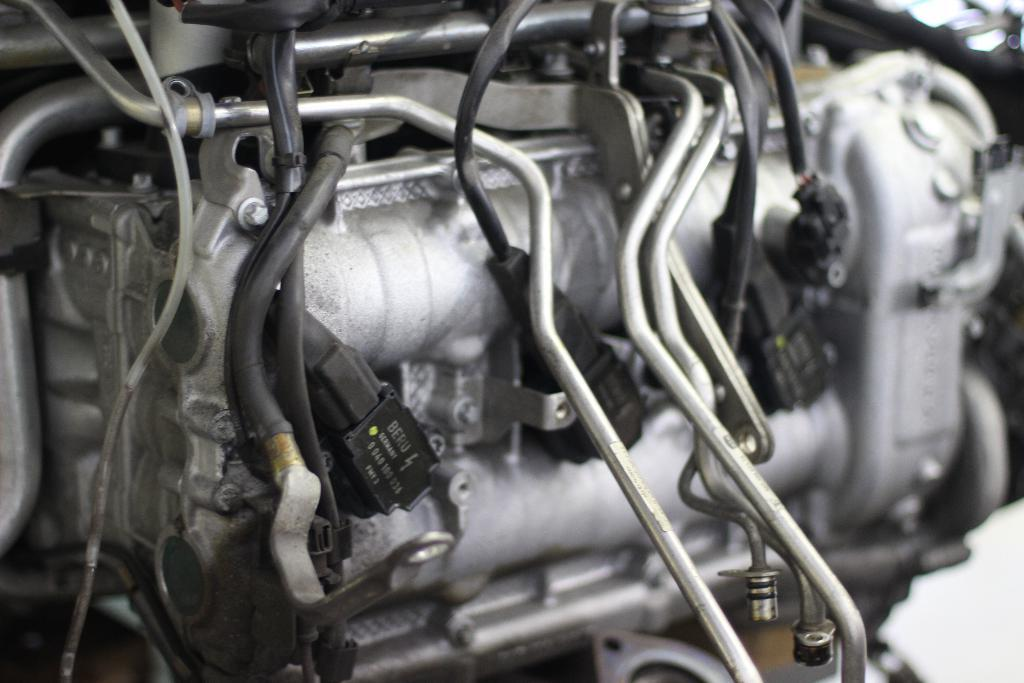What is the main subject of the image? The main subject of the image is an engine. What are some features of the engine? There are cables, screws, and iron objects on the engine. Can you describe the background of the image? The background of the image is blurred. What type of animal can be seen interacting with the engine in the image? There is no animal present in the image; it features an engine with various components. Is there a notebook visible on the engine in the image? There is no notebook present in the image; it only shows an engine with cables, screws, and iron objects. 